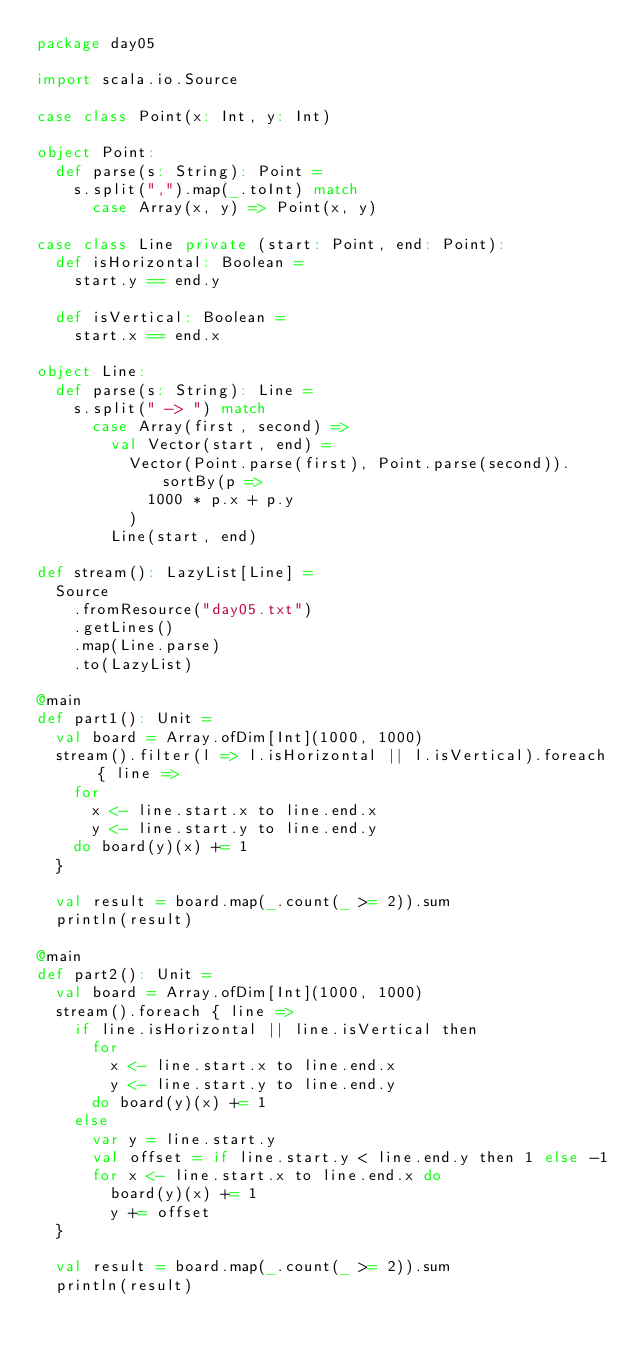Convert code to text. <code><loc_0><loc_0><loc_500><loc_500><_Scala_>package day05

import scala.io.Source

case class Point(x: Int, y: Int)

object Point:
  def parse(s: String): Point =
    s.split(",").map(_.toInt) match
      case Array(x, y) => Point(x, y)

case class Line private (start: Point, end: Point):
  def isHorizontal: Boolean =
    start.y == end.y

  def isVertical: Boolean =
    start.x == end.x

object Line:
  def parse(s: String): Line =
    s.split(" -> ") match
      case Array(first, second) =>
        val Vector(start, end) =
          Vector(Point.parse(first), Point.parse(second)).sortBy(p =>
            1000 * p.x + p.y
          )
        Line(start, end)

def stream(): LazyList[Line] =
  Source
    .fromResource("day05.txt")
    .getLines()
    .map(Line.parse)
    .to(LazyList)

@main
def part1(): Unit =
  val board = Array.ofDim[Int](1000, 1000)
  stream().filter(l => l.isHorizontal || l.isVertical).foreach { line =>
    for
      x <- line.start.x to line.end.x
      y <- line.start.y to line.end.y
    do board(y)(x) += 1
  }

  val result = board.map(_.count(_ >= 2)).sum
  println(result)

@main
def part2(): Unit =
  val board = Array.ofDim[Int](1000, 1000)
  stream().foreach { line =>
    if line.isHorizontal || line.isVertical then
      for
        x <- line.start.x to line.end.x
        y <- line.start.y to line.end.y
      do board(y)(x) += 1
    else
      var y = line.start.y
      val offset = if line.start.y < line.end.y then 1 else -1
      for x <- line.start.x to line.end.x do
        board(y)(x) += 1
        y += offset
  }

  val result = board.map(_.count(_ >= 2)).sum
  println(result)
</code> 